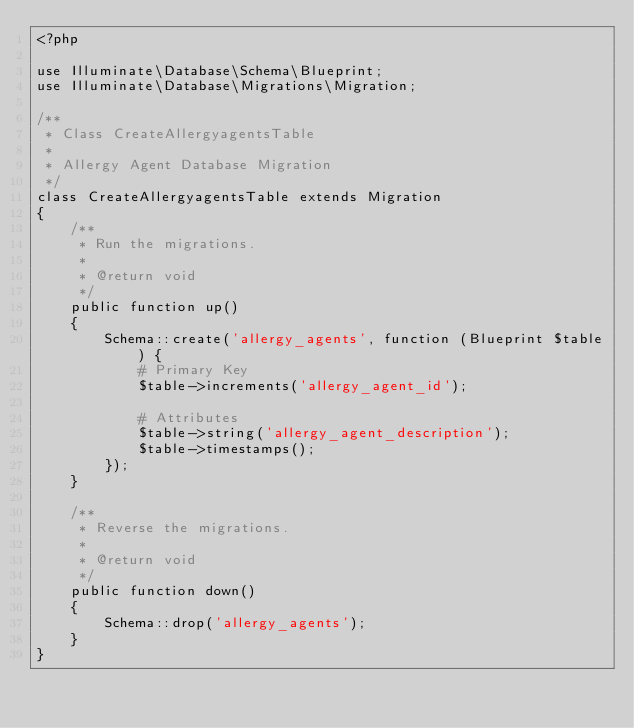<code> <loc_0><loc_0><loc_500><loc_500><_PHP_><?php

use Illuminate\Database\Schema\Blueprint;
use Illuminate\Database\Migrations\Migration;

/**
 * Class CreateAllergyagentsTable
 * 
 * Allergy Agent Database Migration
 */
class CreateAllergyagentsTable extends Migration
{
    /**
     * Run the migrations.
     *
     * @return void
     */
    public function up()
    {
        Schema::create('allergy_agents', function (Blueprint $table) {
            # Primary Key
            $table->increments('allergy_agent_id');
            
            # Attributes
            $table->string('allergy_agent_description');
            $table->timestamps();
        });
    }

    /**
     * Reverse the migrations.
     *
     * @return void
     */
    public function down()
    {
        Schema::drop('allergy_agents');
    }
}
</code> 